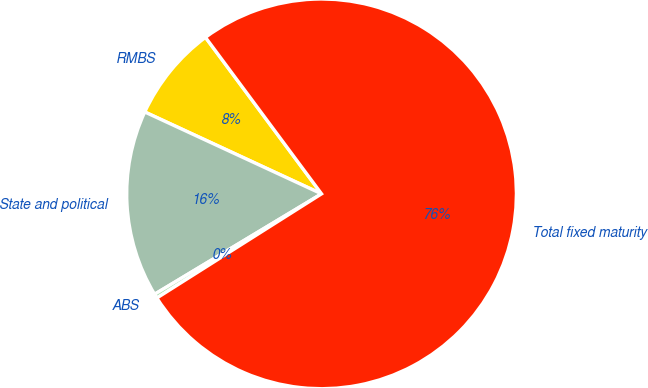Convert chart to OTSL. <chart><loc_0><loc_0><loc_500><loc_500><pie_chart><fcel>RMBS<fcel>State and political<fcel>ABS<fcel>Total fixed maturity<nl><fcel>7.94%<fcel>15.52%<fcel>0.36%<fcel>76.18%<nl></chart> 